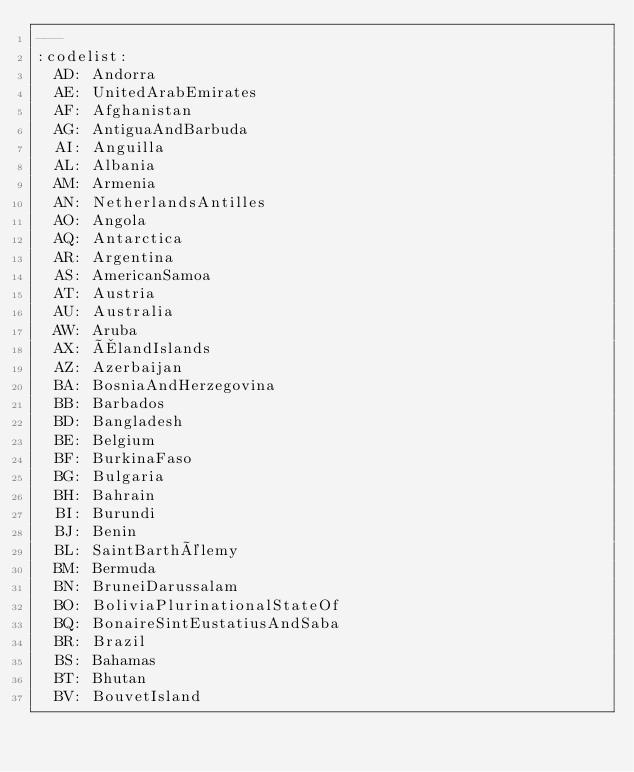<code> <loc_0><loc_0><loc_500><loc_500><_YAML_>---
:codelist:
  AD: Andorra
  AE: UnitedArabEmirates
  AF: Afghanistan
  AG: AntiguaAndBarbuda
  AI: Anguilla
  AL: Albania
  AM: Armenia
  AN: NetherlandsAntilles
  AO: Angola
  AQ: Antarctica
  AR: Argentina
  AS: AmericanSamoa
  AT: Austria
  AU: Australia
  AW: Aruba
  AX: ÅlandIslands
  AZ: Azerbaijan
  BA: BosniaAndHerzegovina
  BB: Barbados
  BD: Bangladesh
  BE: Belgium
  BF: BurkinaFaso
  BG: Bulgaria
  BH: Bahrain
  BI: Burundi
  BJ: Benin
  BL: SaintBarthélemy
  BM: Bermuda
  BN: BruneiDarussalam
  BO: BoliviaPlurinationalStateOf
  BQ: BonaireSintEustatiusAndSaba
  BR: Brazil
  BS: Bahamas
  BT: Bhutan
  BV: BouvetIsland</code> 